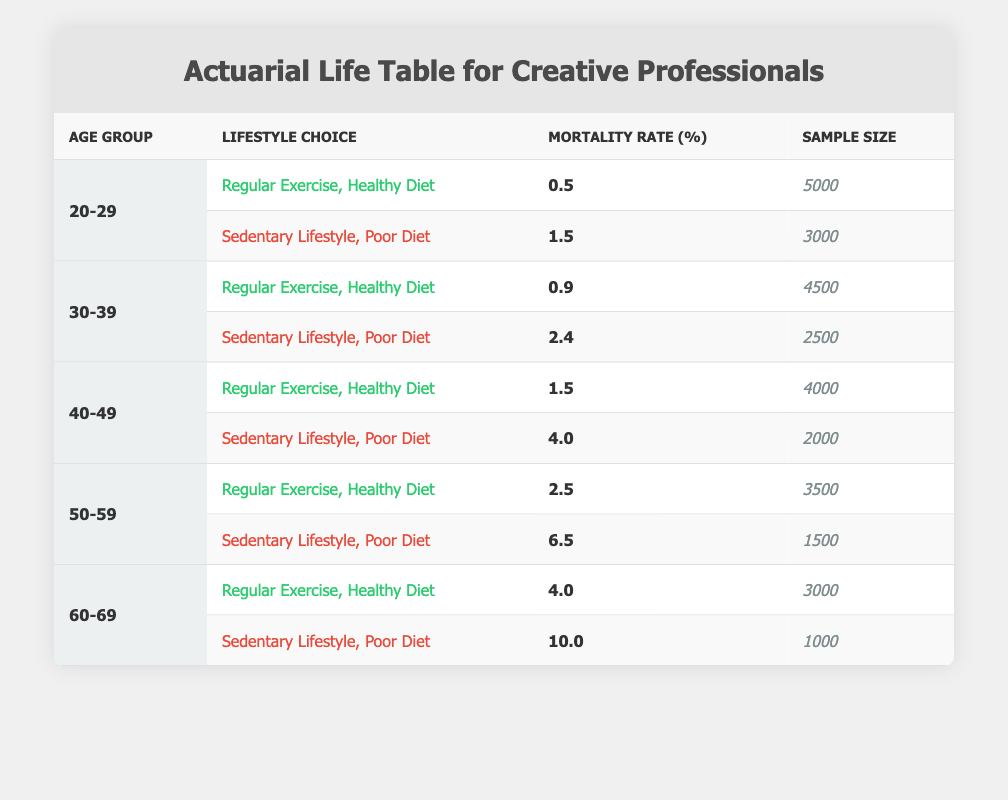What is the mortality rate for 20-29 year-olds with a sedentary lifestyle and poor diet? The table shows a specific entry for the age group 20-29 with a sedentary lifestyle and poor diet, which lists a mortality rate of 1.5%.
Answer: 1.5% Which age group has the highest mortality rate for individuals engaging in regular exercise and a healthy diet? The data reveals the following mortality rates for regular exercise and a healthy diet: 0.5% for 20-29, 0.9% for 30-39, 1.5% for 40-49, 2.5% for 50-59, and 4.0% for 60-69. The highest among these is 4.0% for the 60-69 age group.
Answer: 4.0% What is the sample size of those aged 30-39 who follow a sedentary lifestyle and poor diet? In the 30-39 age group, there is an entry that indicates the sample size for those with a sedentary lifestyle and poor diet is 2500.
Answer: 2500 If we compare the mortality rates, how much higher is the mortality rate for 50-59 year-olds with a sedentary lifestyle and poor diet compared to those with a regular exercise and healthy diet? The mortality rate for 50-59 year-olds with a sedentary lifestyle and poor diet is 6.5%, while the rate for those with regular exercise and a healthy diet is 2.5%. The difference is calculated as 6.5% - 2.5% = 4.0%.
Answer: 4.0% Is the mortality rate for 60-69 year-olds with a sedentary lifestyle and poor diet greater than that for 30-39 year-olds with the same lifestyle? The mortality rate for 60-69 year-olds with a sedentary lifestyle and poor diet is 10.0%, while for 30-39 year-olds it is 2.4%. Since 10.0% is greater than 2.4%, the statement is true.
Answer: Yes What are the average mortality rates for all age groups that engage in regular exercise and a healthy diet? The mortality rates for regular exercise and a healthy diet are as follows: 0.5% (20-29), 0.9% (30-39), 1.5% (40-49), 2.5% (50-59), and 4.0% (60-69). The average can be calculated as (0.5 + 0.9 + 1.5 + 2.5 + 4.0) / 5 = 1.48%.
Answer: 1.48% Are there more individuals in the sample size for the 40-49 age group with a sedentary lifestyle and poor diet than the same age group with a regular exercise and healthy diet? The sample size for the 40-49 age group with a sedentary lifestyle and poor diet is 2000, while for regular exercise and a healthy diet it is 4000. Since 2000 is less than 4000, the answer is no.
Answer: No 